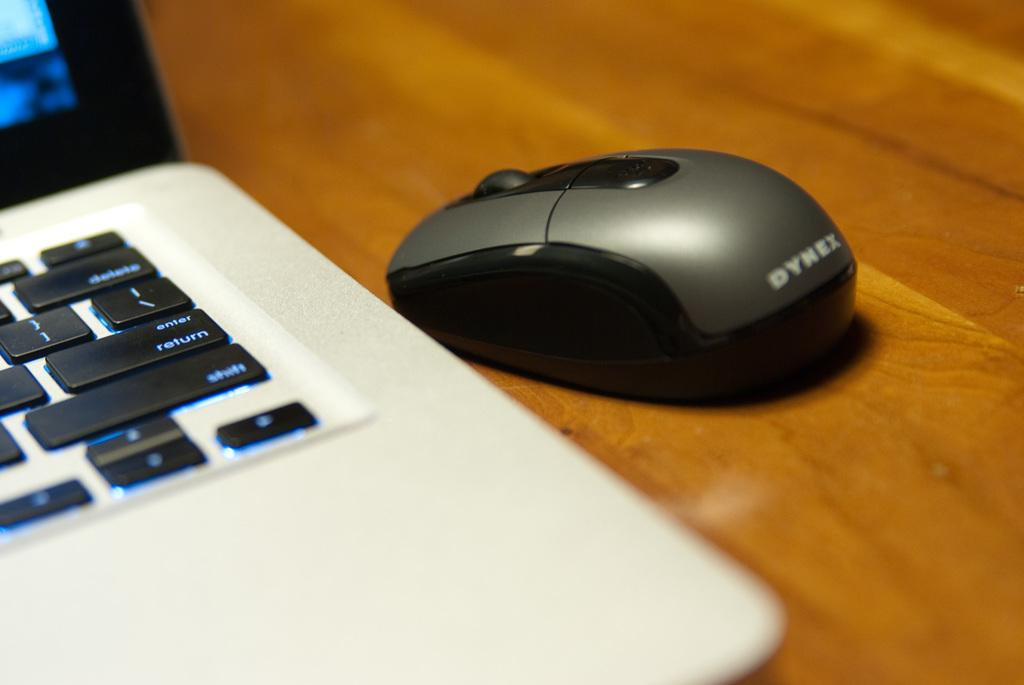<image>
Render a clear and concise summary of the photo. White and black laptop that includes a syrex wireless mouse 